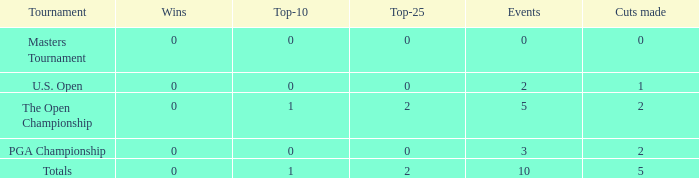What is the total of top-10s for occasions with over 0 victories? None. 